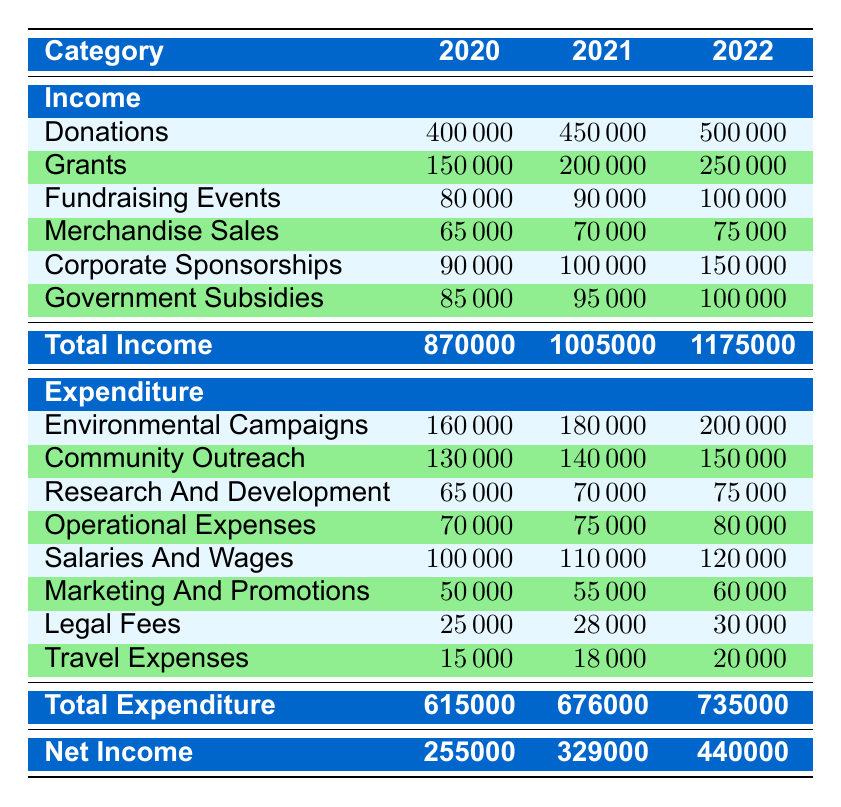What was the total income in 2022? The total income for 2022 is presented in the table under "Total Income" for that year, which is 1,175,000.
Answer: 1,175,000 Which year had the highest expenditure? To find the highest expenditure, we compare the total expenditure for each year listed in the table: 615,000 for 2020, 676,000 for 2021, and 735,000 for 2022. The highest value is 735,000 in 2022.
Answer: 2022 What is the difference between total income in 2021 and total expenditure in 2021? We first identify the total income in 2021, which is 1,005,000, and the total expenditure in 2021, which is 676,000. The difference is calculated as 1,005,000 - 676,000 = 329,000.
Answer: 329,000 True or False: The income from donations increased each year from 2020 to 2022. We look at the donations for each year: 400,000 in 2020, 450,000 in 2021, and 500,000 in 2022. Since the values increase each year, the statement is true.
Answer: True What is the average expenditure on community outreach over the three years? We find the community outreach expenditure for each year: 130,000 in 2020, 140,000 in 2021, and 150,000 in 2022. To calculate the average, sum these values: 130,000 + 140,000 + 150,000 = 420,000. Divide by 3 to find the average: 420,000 / 3 = 140,000.
Answer: 140,000 In which year was the net income the largest, and what was the amount? The net income is found under "Net Income" for each year: 255,000 for 2020, 329,000 for 2021, and 440,000 for 2022. The largest amount is 440,000 in 2022.
Answer: 2022, 440,000 Did the income from corporate sponsorships see a drop in any year? We examine the corporate sponsorship income for the years: 90,000 in 2020, 100,000 in 2021, and 150,000 in 2022. Since there is no drop in any year, the answer is no.
Answer: No What proportion of total income in 2022 came from donations? The total income for 2022 is 1,175,000, and the donations for that year are 500,000. To find the proportion, we calculate 500,000 / 1,175,000, resulting in approximately 0.4265 or 42.65%.
Answer: 42.65% 